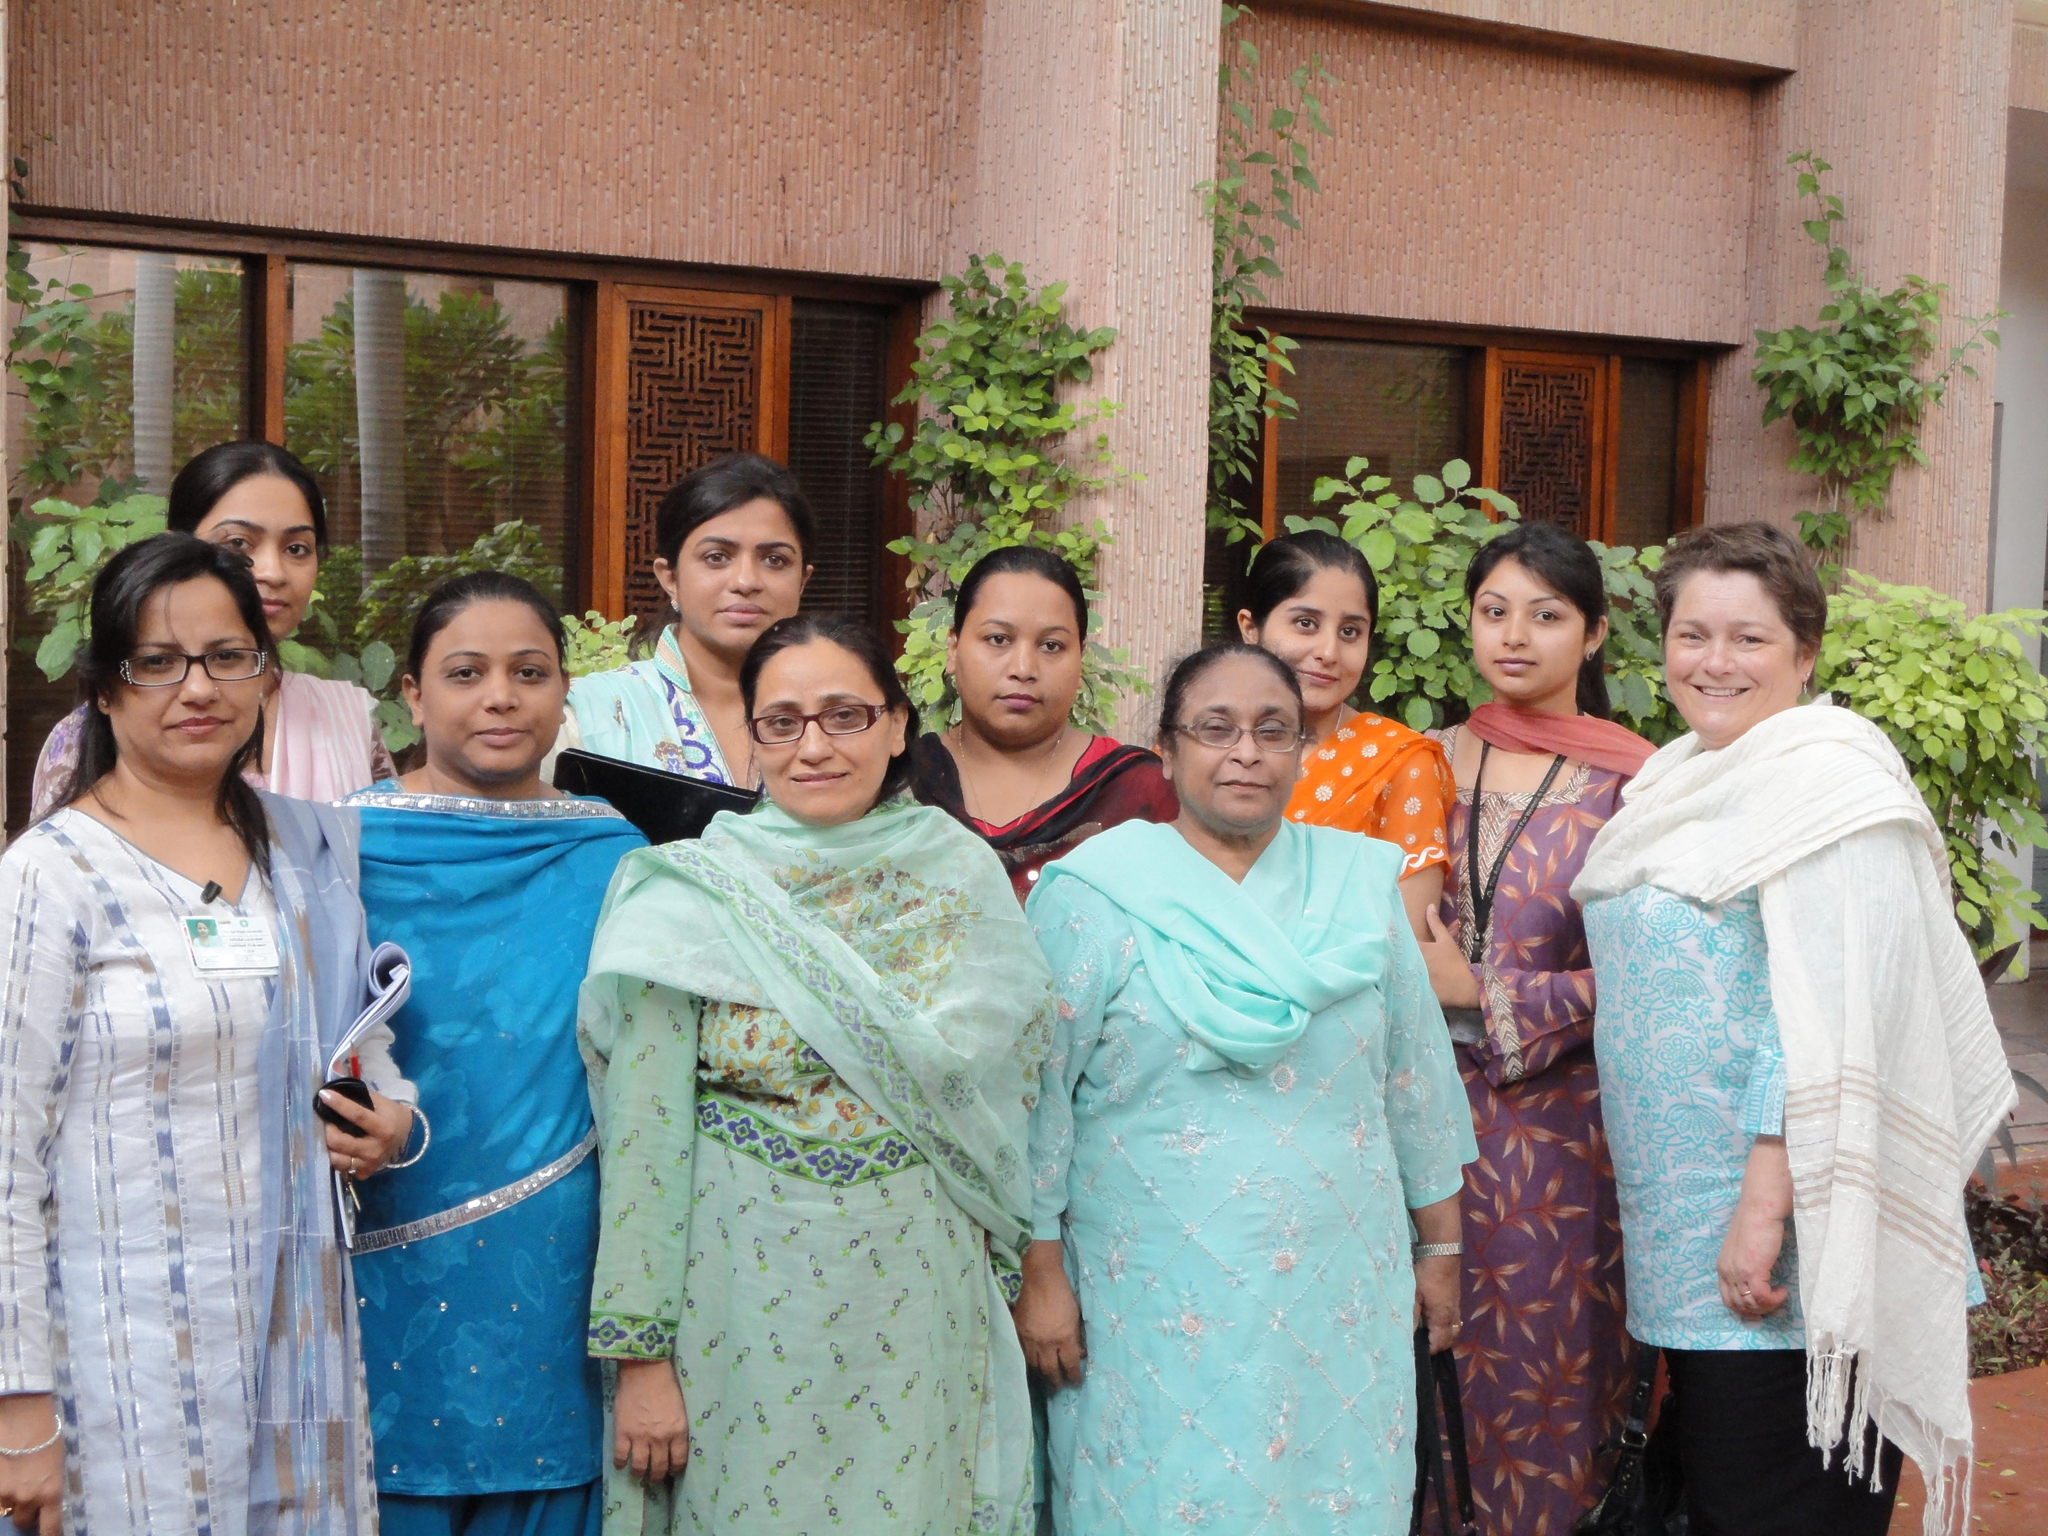What is the main subject of the image? The main subject of the image is a group of ladies. What are the ladies doing in the image? The ladies are standing and smiling. What can be seen in the background of the image? There are plants and a building visible in the background of the image. What type of haircut is the lady on the right getting in the image? There is no haircut or any tools like scissors present in the image. What color bead is the lady in the middle wearing in the image? There is no bead visible on any of the ladies in the image. 